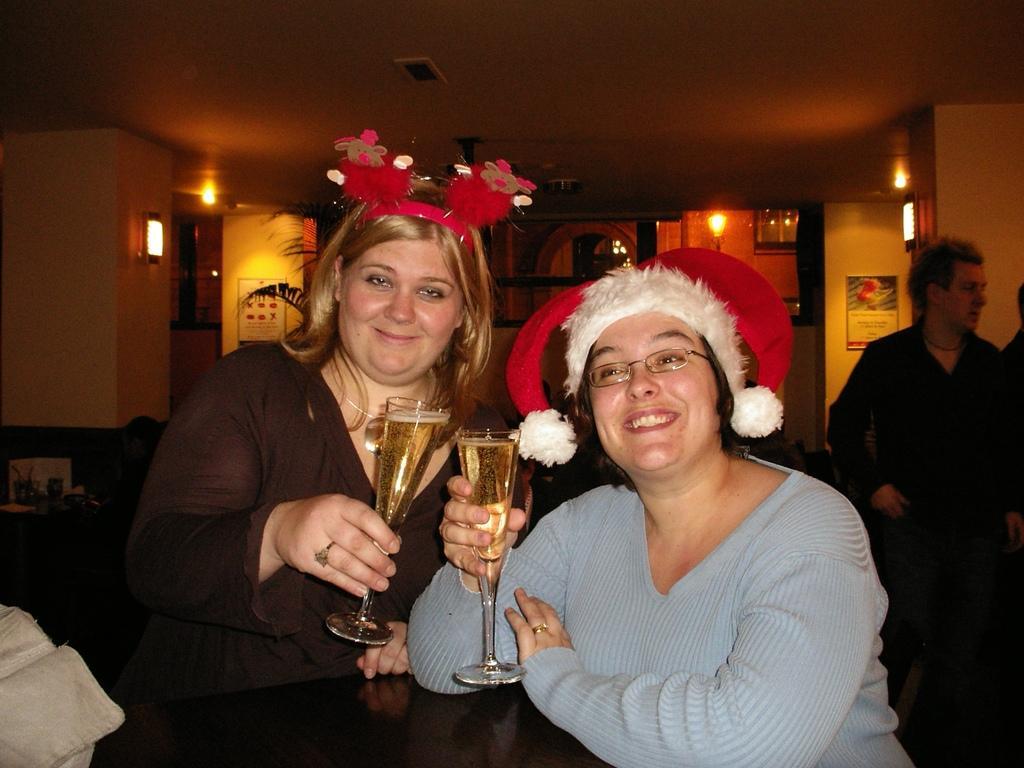In one or two sentences, can you explain what this image depicts? there are two women standing and holding a glass with a liquid. 